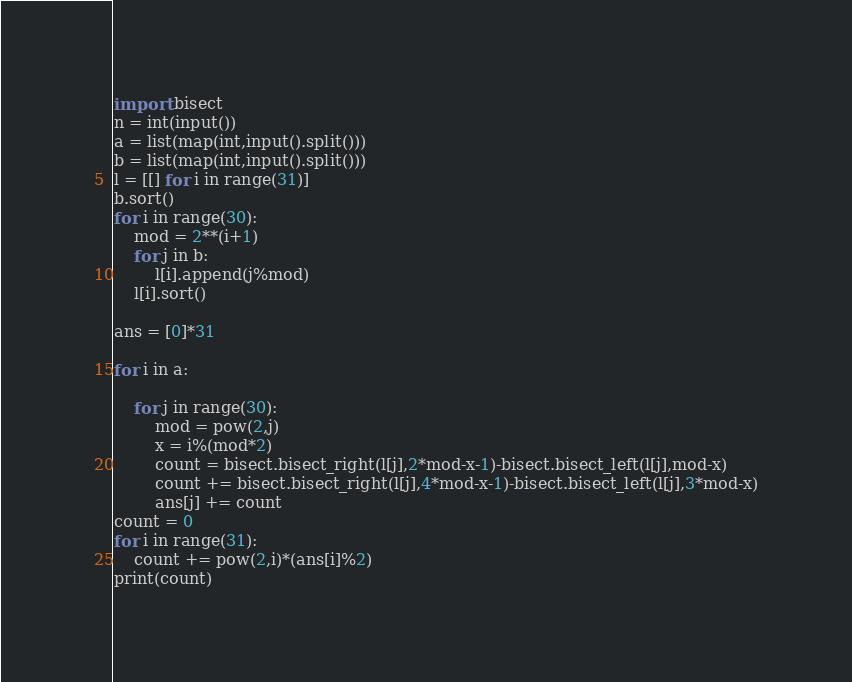<code> <loc_0><loc_0><loc_500><loc_500><_Python_>import bisect
n = int(input())
a = list(map(int,input().split()))
b = list(map(int,input().split()))
l = [[] for i in range(31)]
b.sort()
for i in range(30):
    mod = 2**(i+1)
    for j in b:
        l[i].append(j%mod)
    l[i].sort()

ans = [0]*31

for i in a:
    
    for j in range(30):
        mod = pow(2,j)
        x = i%(mod*2)
        count = bisect.bisect_right(l[j],2*mod-x-1)-bisect.bisect_left(l[j],mod-x)
        count += bisect.bisect_right(l[j],4*mod-x-1)-bisect.bisect_left(l[j],3*mod-x)
        ans[j] += count
count = 0
for i in range(31):
    count += pow(2,i)*(ans[i]%2)
print(count)</code> 